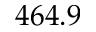Convert formula to latex. <formula><loc_0><loc_0><loc_500><loc_500>4 6 4 . 9</formula> 